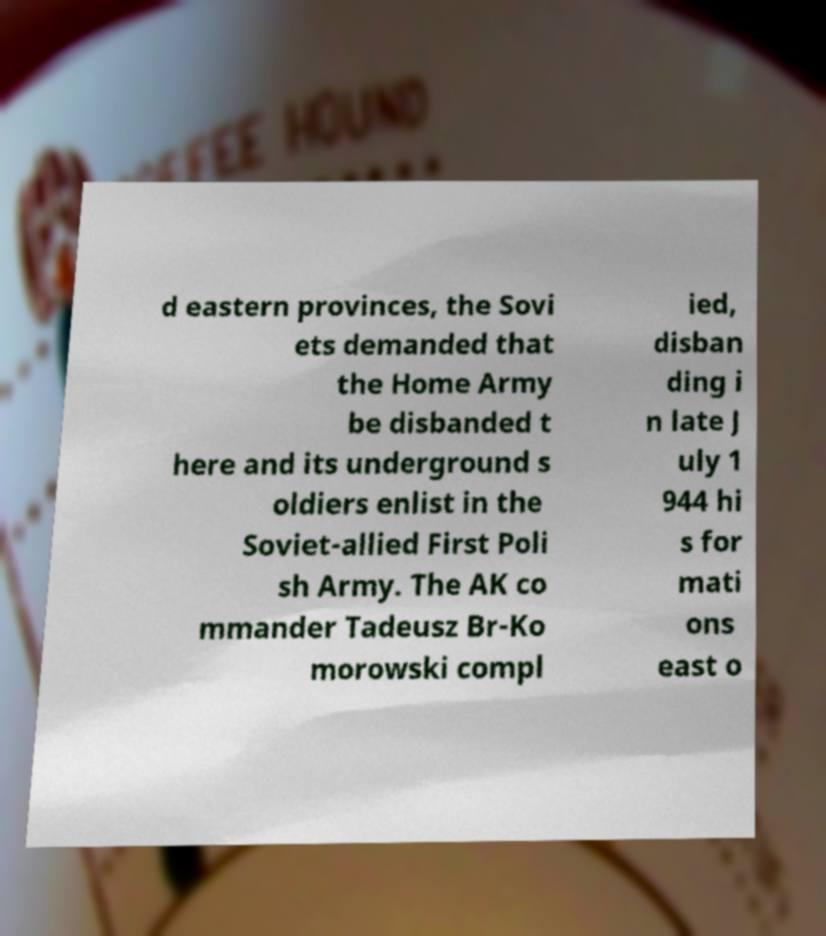Can you accurately transcribe the text from the provided image for me? d eastern provinces, the Sovi ets demanded that the Home Army be disbanded t here and its underground s oldiers enlist in the Soviet-allied First Poli sh Army. The AK co mmander Tadeusz Br-Ko morowski compl ied, disban ding i n late J uly 1 944 hi s for mati ons east o 